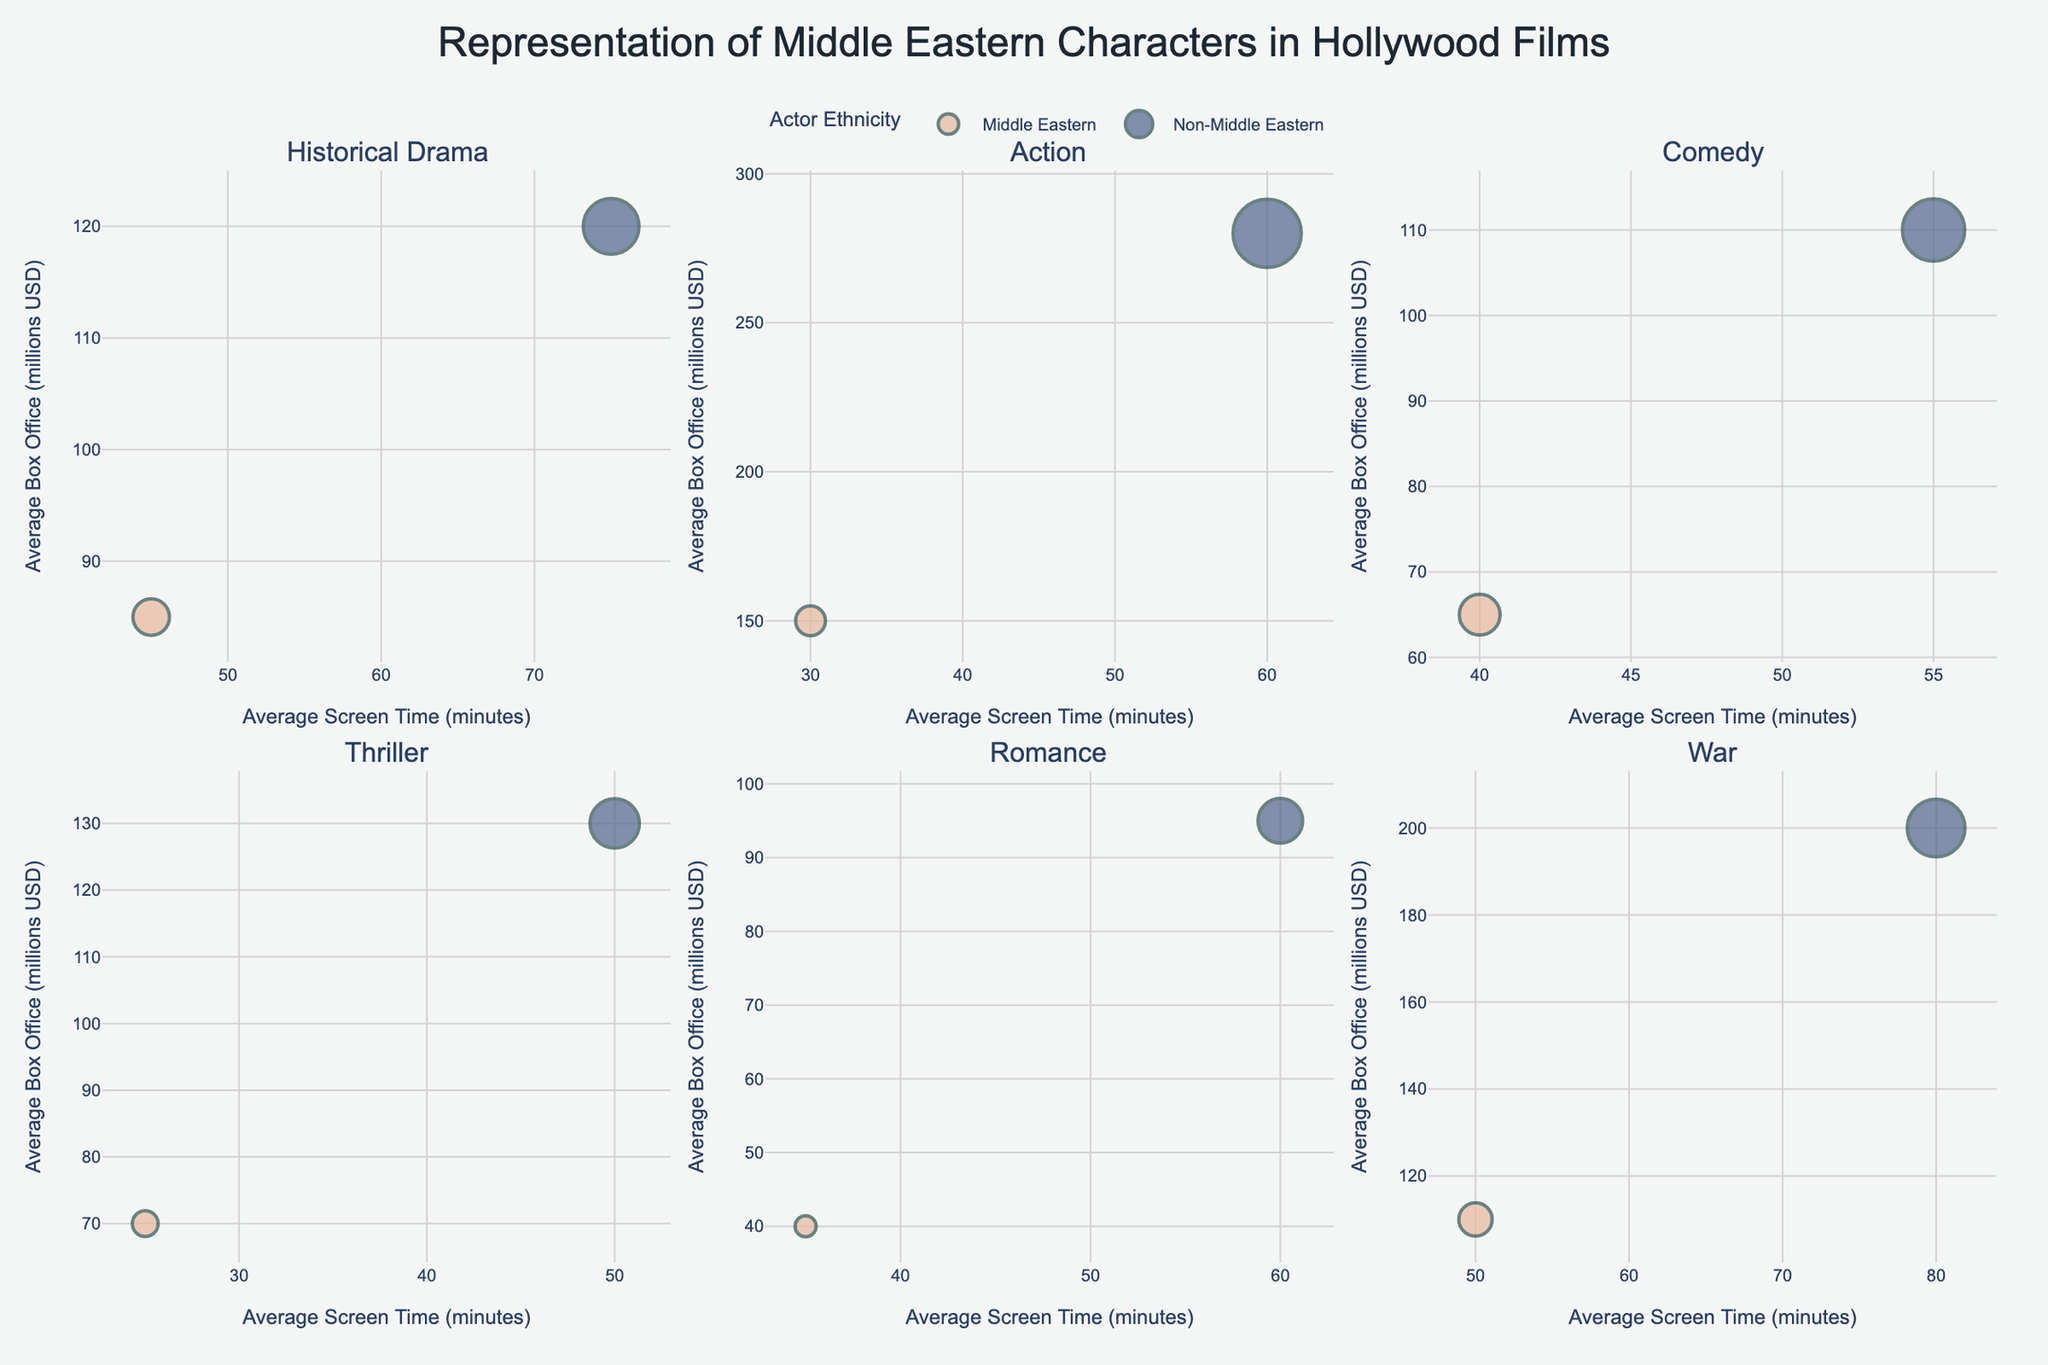Which genre has the highest average box office for Middle Eastern actors? The highest average box office for Middle Eastern actors is shown by the size of the bubbles and their y-axis position. For Middle Eastern actors, the action genre has the highest average box office with $150 million.
Answer: Action How does the average screen time of Middle Eastern actors in historical dramas compare to that in comedies? By comparing the x-axis values of Middle Eastern actors in historical dramas (45 minutes) and comedies (40 minutes), we see that Middle Eastern actors have slightly more average screen time in historical dramas.
Answer: More in historical dramas Which genre has the smallest bubble for Middle Eastern actors in terms of the number of films? The smallest bubble for Middle Eastern actors, indicating the fewest number of films, appears in the romance genre.
Answer: Romance What is the difference in average box office earnings between Middle Eastern and Non-Middle Eastern actors in action films? For action films, Middle Eastern actors have an average box office of $150 million while Non-Middle Eastern actors have $280 million. The difference is $280 million - $150 million = $130 million.
Answer: $130 million What is the average number of films across all genres for Non-Middle Eastern actors? Summing the number of films for Non-Middle Eastern actors across all genres gives: 28 (Historical Drama) + 42 (Action) + 35 (Comedy) + 22 (Thriller) + 18 (Romance) + 30 (War) = 175. There are 6 genres, so the average is 175 / 6 ≈ 29.17.
Answer: 29.17 How does the representation of Middle Eastern actors in thriller films compare to that in war films in terms of the average screen time? The average screen time for Middle Eastern actors in thrillers is 25 minutes, while in war films it is 50 minutes. Thus, Middle Eastern actors have more average screen time in war films compared to thrillers.
Answer: More in war films Which genre shows the largest difference in average screen time between Middle Eastern and Non-Middle Eastern actors? By comparing the screen time gaps in all genres, romance shows the largest difference: 60 minutes (Non-Middle Eastern) - 35 minutes (Middle Eastern) = 25 minutes.
Answer: Romance Which actor ethnicity has the highest average box office for thriller films? For thriller films, the Non-Middle Eastern actors have the highest average box office at $130 million.
Answer: Non-Middle Eastern What is the total number of films for Middle Eastern actors across all genres? Summing the number of films for Middle Eastern actors across all genres gives: 12 (Historical Drama) + 8 (Action) + 15 (Comedy) + 6 (Thriller) + 4 (Romance) + 10 (War) = 55.
Answer: 55 